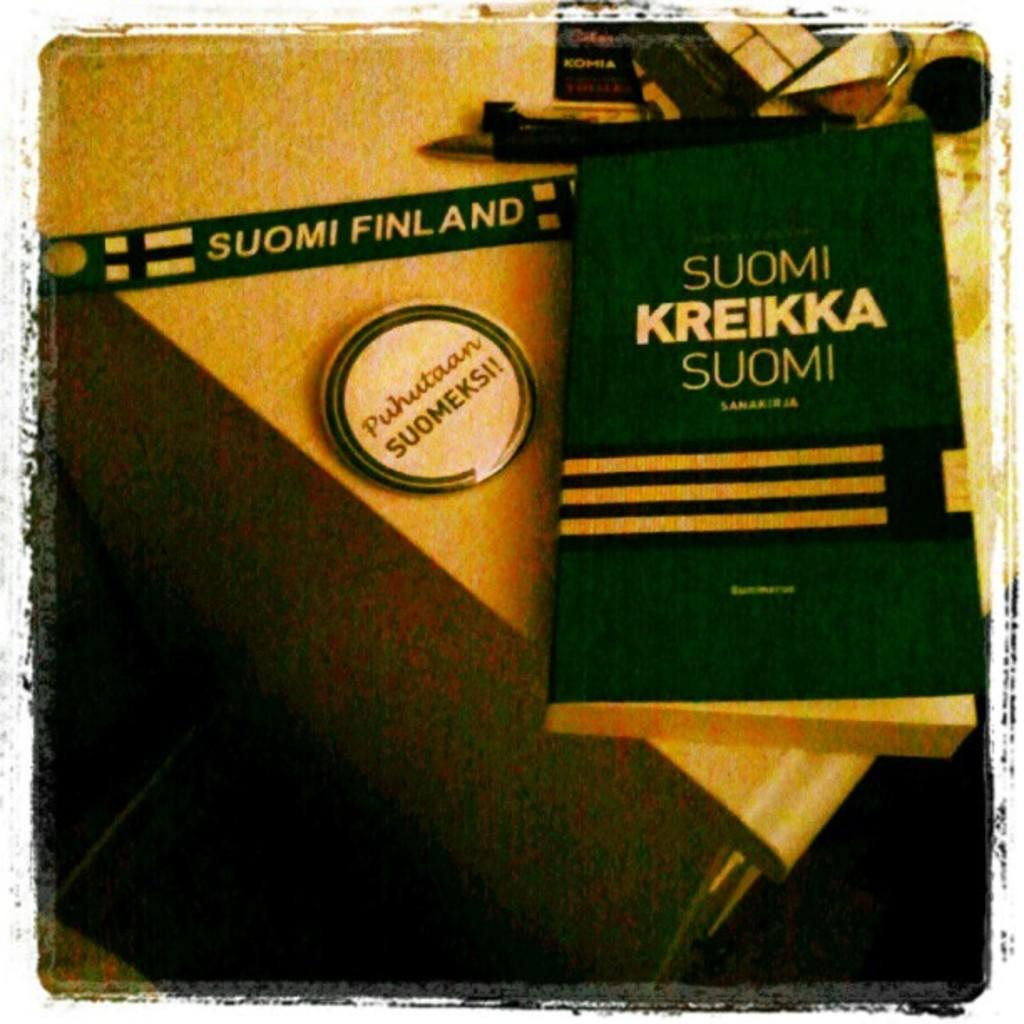<image>
Provide a brief description of the given image. A green book called Suomi Kreikka Suomi is on a counter top. 